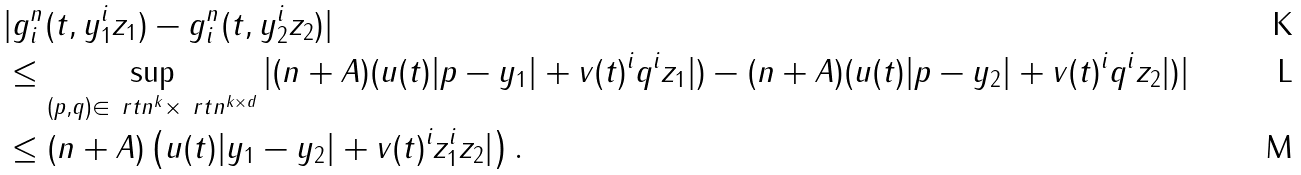<formula> <loc_0><loc_0><loc_500><loc_500>& | g _ { i } ^ { n } ( t , y _ { 1 } ^ { i } z _ { 1 } ) - g _ { i } ^ { n } ( t , y _ { 2 } ^ { i } z _ { 2 } ) | \\ & \leq \sup _ { ( p , q ) \in \ r t n ^ { k } \times \ r t n ^ { k \times d } } | ( n + A ) ( u ( t ) | p - y _ { 1 } | + v ( t ) ^ { i } q ^ { i } z _ { 1 } | ) - ( n + A ) ( u ( t ) | p - y _ { 2 } | + v ( t ) ^ { i } q ^ { i } z _ { 2 } | ) | \\ & \leq ( n + A ) \left ( u ( t ) | y _ { 1 } - y _ { 2 } | + v ( t ) ^ { i } z _ { 1 } ^ { i } z _ { 2 } | \right ) .</formula> 